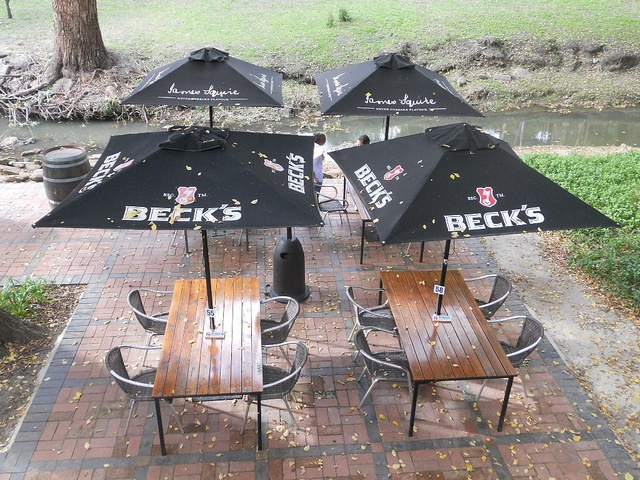Describe the objects in this image and their specific colors. I can see umbrella in beige, black, gray, and lightgray tones, umbrella in beige, gray, black, and white tones, dining table in beige, lightgray, tan, darkgray, and gray tones, dining table in beige, gray, darkgray, and brown tones, and umbrella in beige, gray, darkgray, and black tones in this image. 